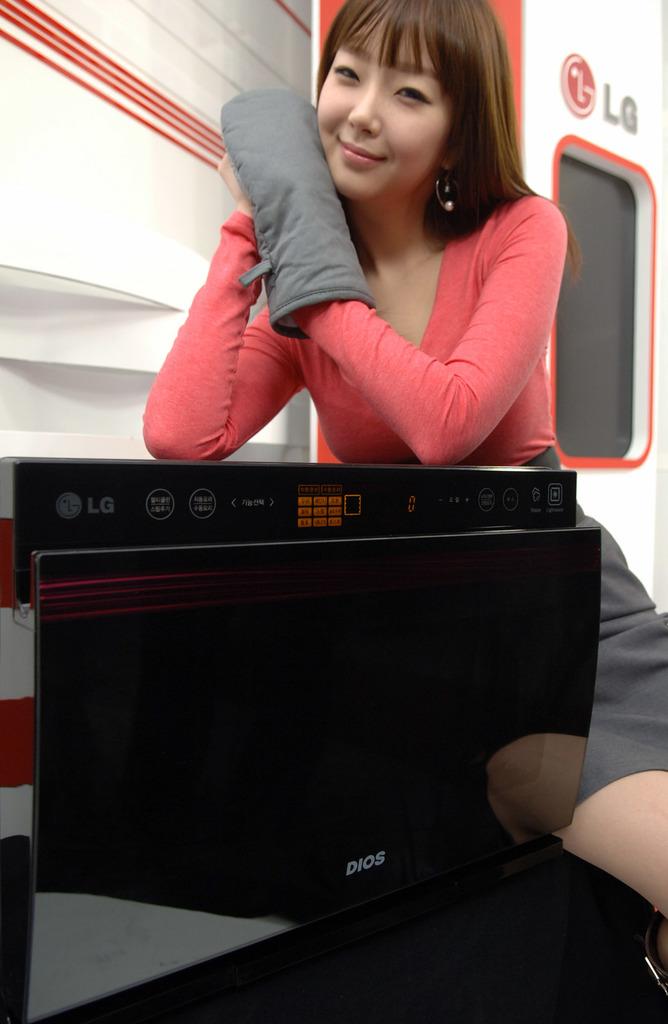Is lg popular among asians?
Offer a terse response. Answering does not require reading text in the image. Some lg brand using?
Provide a short and direct response. Yes. 